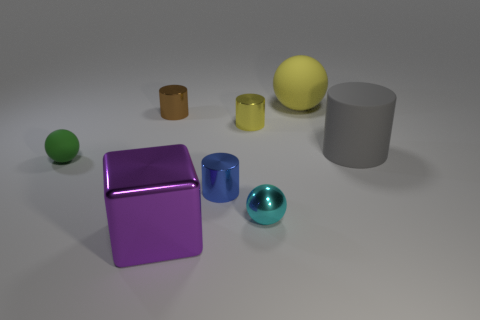Subtract all yellow cylinders. How many cylinders are left? 3 Subtract all large matte cylinders. How many cylinders are left? 3 Subtract all red cylinders. Subtract all blue spheres. How many cylinders are left? 4 Subtract all balls. How many objects are left? 5 Add 3 blue matte things. How many blue matte things exist? 3 Subtract 0 cyan blocks. How many objects are left? 8 Subtract all tiny cyan matte spheres. Subtract all tiny blue things. How many objects are left? 7 Add 1 metal spheres. How many metal spheres are left? 2 